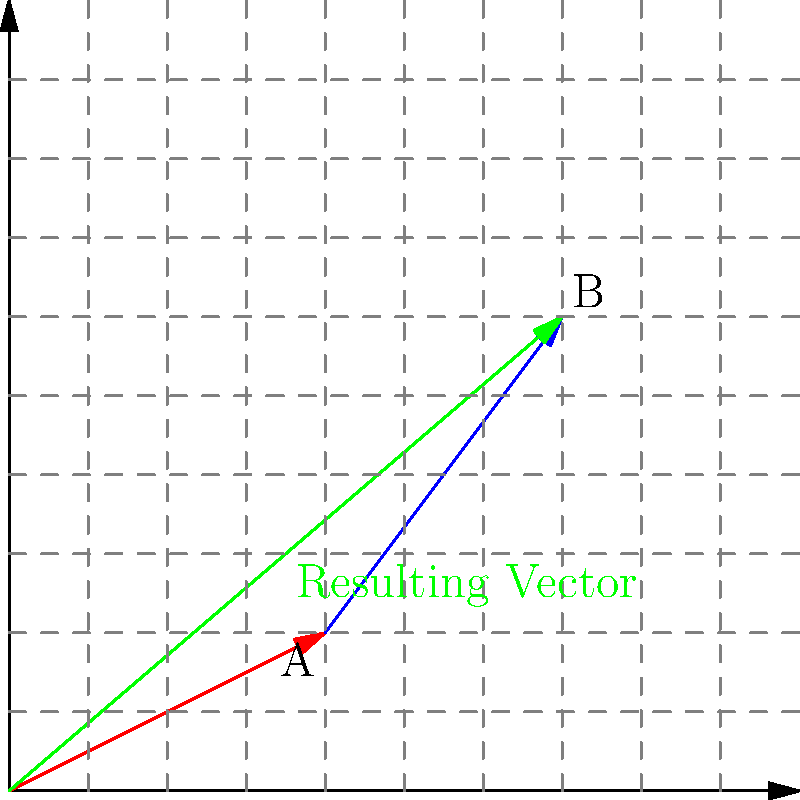A cooperative is planning to optimize its storage facility layout. Two potential routes for moving goods are represented by vectors A (4 units east, 2 units north) and B (3 units east, 4 units north). What is the magnitude of the resulting vector formed by adding these two routes, representing the most efficient path for goods movement? To solve this problem, we need to follow these steps:

1. Identify the components of each vector:
   Vector A: $(4, 2)$
   Vector B: $(3, 4)$

2. Add the vectors component-wise:
   Resulting vector = A + B = $(4+3, 2+4) = (7, 6)$

3. Calculate the magnitude of the resulting vector using the Pythagorean theorem:
   Magnitude = $\sqrt{x^2 + y^2}$
   
   Where $x = 7$ and $y = 6$

4. Plug in the values:
   Magnitude = $\sqrt{7^2 + 6^2}$

5. Simplify:
   Magnitude = $\sqrt{49 + 36} = \sqrt{85}$

6. The final answer is $\sqrt{85}$ units.

This resulting vector represents the most efficient path for goods movement in the storage facility, combining the two original routes into a single, optimized path.
Answer: $\sqrt{85}$ units 